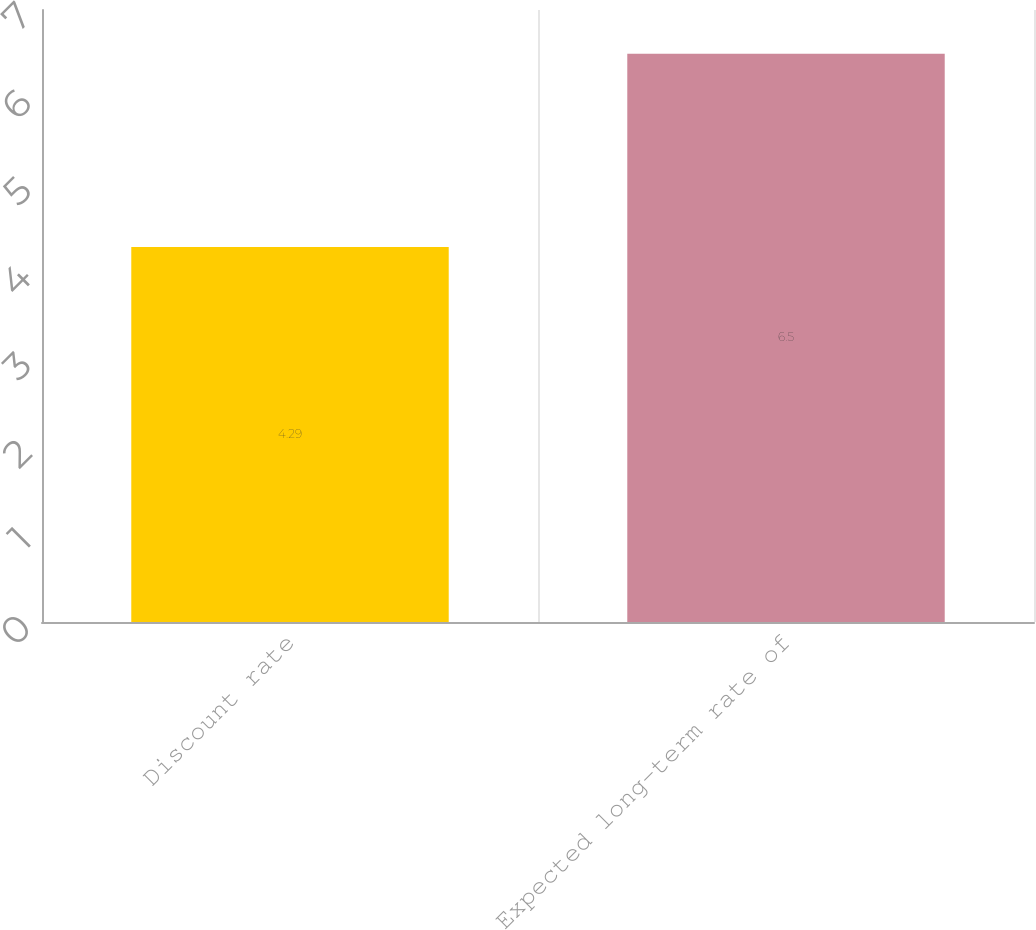Convert chart to OTSL. <chart><loc_0><loc_0><loc_500><loc_500><bar_chart><fcel>Discount rate<fcel>Expected long-term rate of<nl><fcel>4.29<fcel>6.5<nl></chart> 